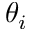<formula> <loc_0><loc_0><loc_500><loc_500>\theta _ { i }</formula> 